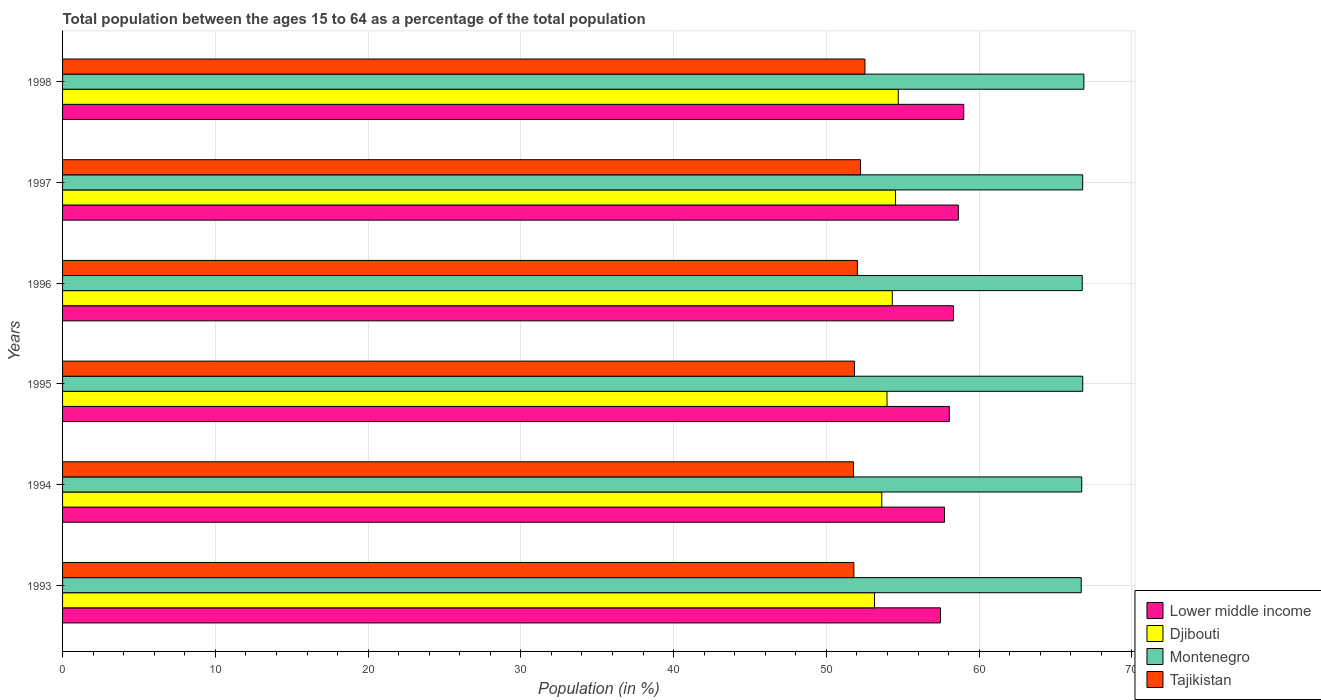How many different coloured bars are there?
Your response must be concise. 4. Are the number of bars per tick equal to the number of legend labels?
Provide a short and direct response. Yes. Are the number of bars on each tick of the Y-axis equal?
Your answer should be very brief. Yes. What is the label of the 5th group of bars from the top?
Give a very brief answer. 1994. What is the percentage of the population ages 15 to 64 in Djibouti in 1996?
Provide a short and direct response. 54.31. Across all years, what is the maximum percentage of the population ages 15 to 64 in Tajikistan?
Provide a succinct answer. 52.52. Across all years, what is the minimum percentage of the population ages 15 to 64 in Tajikistan?
Your answer should be compact. 51.77. What is the total percentage of the population ages 15 to 64 in Djibouti in the graph?
Your answer should be compact. 324.29. What is the difference between the percentage of the population ages 15 to 64 in Montenegro in 1993 and that in 1995?
Ensure brevity in your answer.  -0.1. What is the difference between the percentage of the population ages 15 to 64 in Tajikistan in 1993 and the percentage of the population ages 15 to 64 in Lower middle income in 1996?
Make the answer very short. -6.52. What is the average percentage of the population ages 15 to 64 in Montenegro per year?
Your answer should be compact. 66.76. In the year 1996, what is the difference between the percentage of the population ages 15 to 64 in Lower middle income and percentage of the population ages 15 to 64 in Djibouti?
Offer a terse response. 4. What is the ratio of the percentage of the population ages 15 to 64 in Lower middle income in 1995 to that in 1997?
Offer a very short reply. 0.99. What is the difference between the highest and the second highest percentage of the population ages 15 to 64 in Tajikistan?
Ensure brevity in your answer.  0.29. What is the difference between the highest and the lowest percentage of the population ages 15 to 64 in Tajikistan?
Offer a terse response. 0.75. What does the 4th bar from the top in 1994 represents?
Keep it short and to the point. Lower middle income. What does the 1st bar from the bottom in 1996 represents?
Give a very brief answer. Lower middle income. Are all the bars in the graph horizontal?
Ensure brevity in your answer.  Yes. How many years are there in the graph?
Offer a very short reply. 6. Are the values on the major ticks of X-axis written in scientific E-notation?
Offer a terse response. No. How many legend labels are there?
Make the answer very short. 4. What is the title of the graph?
Offer a terse response. Total population between the ages 15 to 64 as a percentage of the total population. Does "Benin" appear as one of the legend labels in the graph?
Give a very brief answer. No. What is the Population (in %) of Lower middle income in 1993?
Give a very brief answer. 57.47. What is the Population (in %) in Djibouti in 1993?
Your answer should be very brief. 53.15. What is the Population (in %) of Montenegro in 1993?
Ensure brevity in your answer.  66.68. What is the Population (in %) in Tajikistan in 1993?
Provide a succinct answer. 51.8. What is the Population (in %) in Lower middle income in 1994?
Provide a succinct answer. 57.73. What is the Population (in %) in Djibouti in 1994?
Make the answer very short. 53.62. What is the Population (in %) in Montenegro in 1994?
Ensure brevity in your answer.  66.71. What is the Population (in %) in Tajikistan in 1994?
Provide a short and direct response. 51.77. What is the Population (in %) in Lower middle income in 1995?
Your answer should be compact. 58.05. What is the Population (in %) of Djibouti in 1995?
Offer a very short reply. 53.97. What is the Population (in %) of Montenegro in 1995?
Provide a short and direct response. 66.78. What is the Population (in %) of Tajikistan in 1995?
Give a very brief answer. 51.84. What is the Population (in %) in Lower middle income in 1996?
Provide a succinct answer. 58.32. What is the Population (in %) of Djibouti in 1996?
Offer a terse response. 54.31. What is the Population (in %) of Montenegro in 1996?
Offer a terse response. 66.75. What is the Population (in %) in Tajikistan in 1996?
Make the answer very short. 52.03. What is the Population (in %) in Lower middle income in 1997?
Offer a terse response. 58.64. What is the Population (in %) in Djibouti in 1997?
Your answer should be very brief. 54.53. What is the Population (in %) of Montenegro in 1997?
Your answer should be very brief. 66.78. What is the Population (in %) in Tajikistan in 1997?
Keep it short and to the point. 52.24. What is the Population (in %) of Lower middle income in 1998?
Your answer should be compact. 58.99. What is the Population (in %) in Djibouti in 1998?
Ensure brevity in your answer.  54.71. What is the Population (in %) of Montenegro in 1998?
Provide a succinct answer. 66.85. What is the Population (in %) in Tajikistan in 1998?
Give a very brief answer. 52.52. Across all years, what is the maximum Population (in %) of Lower middle income?
Give a very brief answer. 58.99. Across all years, what is the maximum Population (in %) in Djibouti?
Your answer should be very brief. 54.71. Across all years, what is the maximum Population (in %) in Montenegro?
Make the answer very short. 66.85. Across all years, what is the maximum Population (in %) of Tajikistan?
Your answer should be very brief. 52.52. Across all years, what is the minimum Population (in %) in Lower middle income?
Your answer should be very brief. 57.47. Across all years, what is the minimum Population (in %) in Djibouti?
Your answer should be compact. 53.15. Across all years, what is the minimum Population (in %) in Montenegro?
Make the answer very short. 66.68. Across all years, what is the minimum Population (in %) in Tajikistan?
Provide a short and direct response. 51.77. What is the total Population (in %) of Lower middle income in the graph?
Make the answer very short. 349.19. What is the total Population (in %) of Djibouti in the graph?
Keep it short and to the point. 324.29. What is the total Population (in %) of Montenegro in the graph?
Offer a terse response. 400.55. What is the total Population (in %) of Tajikistan in the graph?
Your answer should be very brief. 312.19. What is the difference between the Population (in %) of Lower middle income in 1993 and that in 1994?
Make the answer very short. -0.27. What is the difference between the Population (in %) in Djibouti in 1993 and that in 1994?
Keep it short and to the point. -0.47. What is the difference between the Population (in %) in Montenegro in 1993 and that in 1994?
Your answer should be very brief. -0.03. What is the difference between the Population (in %) in Tajikistan in 1993 and that in 1994?
Ensure brevity in your answer.  0.02. What is the difference between the Population (in %) of Lower middle income in 1993 and that in 1995?
Provide a short and direct response. -0.58. What is the difference between the Population (in %) of Djibouti in 1993 and that in 1995?
Provide a succinct answer. -0.81. What is the difference between the Population (in %) of Montenegro in 1993 and that in 1995?
Keep it short and to the point. -0.1. What is the difference between the Population (in %) in Tajikistan in 1993 and that in 1995?
Your answer should be very brief. -0.04. What is the difference between the Population (in %) of Lower middle income in 1993 and that in 1996?
Your answer should be compact. -0.85. What is the difference between the Population (in %) in Djibouti in 1993 and that in 1996?
Keep it short and to the point. -1.16. What is the difference between the Population (in %) in Montenegro in 1993 and that in 1996?
Your answer should be compact. -0.07. What is the difference between the Population (in %) of Tajikistan in 1993 and that in 1996?
Offer a very short reply. -0.23. What is the difference between the Population (in %) of Lower middle income in 1993 and that in 1997?
Provide a succinct answer. -1.17. What is the difference between the Population (in %) in Djibouti in 1993 and that in 1997?
Offer a very short reply. -1.38. What is the difference between the Population (in %) of Montenegro in 1993 and that in 1997?
Provide a short and direct response. -0.1. What is the difference between the Population (in %) of Tajikistan in 1993 and that in 1997?
Your response must be concise. -0.44. What is the difference between the Population (in %) in Lower middle income in 1993 and that in 1998?
Offer a very short reply. -1.53. What is the difference between the Population (in %) of Djibouti in 1993 and that in 1998?
Offer a terse response. -1.55. What is the difference between the Population (in %) of Montenegro in 1993 and that in 1998?
Provide a short and direct response. -0.18. What is the difference between the Population (in %) in Tajikistan in 1993 and that in 1998?
Keep it short and to the point. -0.72. What is the difference between the Population (in %) of Lower middle income in 1994 and that in 1995?
Offer a terse response. -0.32. What is the difference between the Population (in %) in Djibouti in 1994 and that in 1995?
Ensure brevity in your answer.  -0.34. What is the difference between the Population (in %) of Montenegro in 1994 and that in 1995?
Provide a succinct answer. -0.07. What is the difference between the Population (in %) of Tajikistan in 1994 and that in 1995?
Give a very brief answer. -0.06. What is the difference between the Population (in %) of Lower middle income in 1994 and that in 1996?
Keep it short and to the point. -0.59. What is the difference between the Population (in %) of Djibouti in 1994 and that in 1996?
Make the answer very short. -0.69. What is the difference between the Population (in %) in Montenegro in 1994 and that in 1996?
Ensure brevity in your answer.  -0.03. What is the difference between the Population (in %) of Tajikistan in 1994 and that in 1996?
Your answer should be compact. -0.25. What is the difference between the Population (in %) in Lower middle income in 1994 and that in 1997?
Offer a terse response. -0.9. What is the difference between the Population (in %) of Djibouti in 1994 and that in 1997?
Offer a very short reply. -0.9. What is the difference between the Population (in %) in Montenegro in 1994 and that in 1997?
Your answer should be compact. -0.06. What is the difference between the Population (in %) of Tajikistan in 1994 and that in 1997?
Your response must be concise. -0.46. What is the difference between the Population (in %) of Lower middle income in 1994 and that in 1998?
Your answer should be compact. -1.26. What is the difference between the Population (in %) in Djibouti in 1994 and that in 1998?
Give a very brief answer. -1.08. What is the difference between the Population (in %) in Montenegro in 1994 and that in 1998?
Offer a very short reply. -0.14. What is the difference between the Population (in %) of Tajikistan in 1994 and that in 1998?
Offer a terse response. -0.75. What is the difference between the Population (in %) in Lower middle income in 1995 and that in 1996?
Provide a short and direct response. -0.27. What is the difference between the Population (in %) in Djibouti in 1995 and that in 1996?
Your answer should be very brief. -0.35. What is the difference between the Population (in %) of Montenegro in 1995 and that in 1996?
Offer a terse response. 0.03. What is the difference between the Population (in %) in Tajikistan in 1995 and that in 1996?
Offer a very short reply. -0.19. What is the difference between the Population (in %) in Lower middle income in 1995 and that in 1997?
Give a very brief answer. -0.59. What is the difference between the Population (in %) of Djibouti in 1995 and that in 1997?
Offer a terse response. -0.56. What is the difference between the Population (in %) in Montenegro in 1995 and that in 1997?
Your answer should be compact. 0. What is the difference between the Population (in %) in Tajikistan in 1995 and that in 1997?
Provide a succinct answer. -0.4. What is the difference between the Population (in %) of Lower middle income in 1995 and that in 1998?
Offer a very short reply. -0.94. What is the difference between the Population (in %) of Djibouti in 1995 and that in 1998?
Offer a very short reply. -0.74. What is the difference between the Population (in %) of Montenegro in 1995 and that in 1998?
Your answer should be compact. -0.08. What is the difference between the Population (in %) of Tajikistan in 1995 and that in 1998?
Provide a succinct answer. -0.69. What is the difference between the Population (in %) of Lower middle income in 1996 and that in 1997?
Offer a very short reply. -0.32. What is the difference between the Population (in %) in Djibouti in 1996 and that in 1997?
Keep it short and to the point. -0.21. What is the difference between the Population (in %) of Montenegro in 1996 and that in 1997?
Provide a short and direct response. -0.03. What is the difference between the Population (in %) in Tajikistan in 1996 and that in 1997?
Your answer should be very brief. -0.21. What is the difference between the Population (in %) in Lower middle income in 1996 and that in 1998?
Provide a short and direct response. -0.67. What is the difference between the Population (in %) of Djibouti in 1996 and that in 1998?
Provide a succinct answer. -0.39. What is the difference between the Population (in %) in Montenegro in 1996 and that in 1998?
Offer a terse response. -0.11. What is the difference between the Population (in %) of Tajikistan in 1996 and that in 1998?
Provide a succinct answer. -0.5. What is the difference between the Population (in %) of Lower middle income in 1997 and that in 1998?
Provide a succinct answer. -0.36. What is the difference between the Population (in %) of Djibouti in 1997 and that in 1998?
Your answer should be very brief. -0.18. What is the difference between the Population (in %) of Montenegro in 1997 and that in 1998?
Keep it short and to the point. -0.08. What is the difference between the Population (in %) in Tajikistan in 1997 and that in 1998?
Ensure brevity in your answer.  -0.29. What is the difference between the Population (in %) in Lower middle income in 1993 and the Population (in %) in Djibouti in 1994?
Provide a succinct answer. 3.84. What is the difference between the Population (in %) of Lower middle income in 1993 and the Population (in %) of Montenegro in 1994?
Your answer should be compact. -9.25. What is the difference between the Population (in %) of Lower middle income in 1993 and the Population (in %) of Tajikistan in 1994?
Give a very brief answer. 5.69. What is the difference between the Population (in %) in Djibouti in 1993 and the Population (in %) in Montenegro in 1994?
Give a very brief answer. -13.56. What is the difference between the Population (in %) in Djibouti in 1993 and the Population (in %) in Tajikistan in 1994?
Your response must be concise. 1.38. What is the difference between the Population (in %) in Montenegro in 1993 and the Population (in %) in Tajikistan in 1994?
Provide a short and direct response. 14.91. What is the difference between the Population (in %) in Lower middle income in 1993 and the Population (in %) in Djibouti in 1995?
Give a very brief answer. 3.5. What is the difference between the Population (in %) in Lower middle income in 1993 and the Population (in %) in Montenegro in 1995?
Your response must be concise. -9.31. What is the difference between the Population (in %) of Lower middle income in 1993 and the Population (in %) of Tajikistan in 1995?
Provide a short and direct response. 5.63. What is the difference between the Population (in %) in Djibouti in 1993 and the Population (in %) in Montenegro in 1995?
Your answer should be compact. -13.63. What is the difference between the Population (in %) of Djibouti in 1993 and the Population (in %) of Tajikistan in 1995?
Your answer should be compact. 1.32. What is the difference between the Population (in %) of Montenegro in 1993 and the Population (in %) of Tajikistan in 1995?
Your answer should be compact. 14.84. What is the difference between the Population (in %) in Lower middle income in 1993 and the Population (in %) in Djibouti in 1996?
Your response must be concise. 3.15. What is the difference between the Population (in %) of Lower middle income in 1993 and the Population (in %) of Montenegro in 1996?
Provide a short and direct response. -9.28. What is the difference between the Population (in %) in Lower middle income in 1993 and the Population (in %) in Tajikistan in 1996?
Your answer should be very brief. 5.44. What is the difference between the Population (in %) in Djibouti in 1993 and the Population (in %) in Montenegro in 1996?
Provide a short and direct response. -13.59. What is the difference between the Population (in %) in Djibouti in 1993 and the Population (in %) in Tajikistan in 1996?
Your response must be concise. 1.13. What is the difference between the Population (in %) of Montenegro in 1993 and the Population (in %) of Tajikistan in 1996?
Give a very brief answer. 14.65. What is the difference between the Population (in %) of Lower middle income in 1993 and the Population (in %) of Djibouti in 1997?
Provide a short and direct response. 2.94. What is the difference between the Population (in %) in Lower middle income in 1993 and the Population (in %) in Montenegro in 1997?
Your answer should be compact. -9.31. What is the difference between the Population (in %) of Lower middle income in 1993 and the Population (in %) of Tajikistan in 1997?
Provide a short and direct response. 5.23. What is the difference between the Population (in %) of Djibouti in 1993 and the Population (in %) of Montenegro in 1997?
Provide a short and direct response. -13.62. What is the difference between the Population (in %) in Djibouti in 1993 and the Population (in %) in Tajikistan in 1997?
Give a very brief answer. 0.92. What is the difference between the Population (in %) in Montenegro in 1993 and the Population (in %) in Tajikistan in 1997?
Ensure brevity in your answer.  14.44. What is the difference between the Population (in %) of Lower middle income in 1993 and the Population (in %) of Djibouti in 1998?
Make the answer very short. 2.76. What is the difference between the Population (in %) in Lower middle income in 1993 and the Population (in %) in Montenegro in 1998?
Offer a terse response. -9.39. What is the difference between the Population (in %) in Lower middle income in 1993 and the Population (in %) in Tajikistan in 1998?
Make the answer very short. 4.94. What is the difference between the Population (in %) in Djibouti in 1993 and the Population (in %) in Montenegro in 1998?
Your answer should be very brief. -13.7. What is the difference between the Population (in %) in Djibouti in 1993 and the Population (in %) in Tajikistan in 1998?
Keep it short and to the point. 0.63. What is the difference between the Population (in %) in Montenegro in 1993 and the Population (in %) in Tajikistan in 1998?
Offer a very short reply. 14.16. What is the difference between the Population (in %) in Lower middle income in 1994 and the Population (in %) in Djibouti in 1995?
Offer a terse response. 3.77. What is the difference between the Population (in %) in Lower middle income in 1994 and the Population (in %) in Montenegro in 1995?
Your answer should be very brief. -9.05. What is the difference between the Population (in %) of Lower middle income in 1994 and the Population (in %) of Tajikistan in 1995?
Keep it short and to the point. 5.9. What is the difference between the Population (in %) in Djibouti in 1994 and the Population (in %) in Montenegro in 1995?
Keep it short and to the point. -13.16. What is the difference between the Population (in %) in Djibouti in 1994 and the Population (in %) in Tajikistan in 1995?
Your answer should be compact. 1.79. What is the difference between the Population (in %) of Montenegro in 1994 and the Population (in %) of Tajikistan in 1995?
Give a very brief answer. 14.88. What is the difference between the Population (in %) of Lower middle income in 1994 and the Population (in %) of Djibouti in 1996?
Provide a succinct answer. 3.42. What is the difference between the Population (in %) of Lower middle income in 1994 and the Population (in %) of Montenegro in 1996?
Your response must be concise. -9.01. What is the difference between the Population (in %) of Lower middle income in 1994 and the Population (in %) of Tajikistan in 1996?
Keep it short and to the point. 5.71. What is the difference between the Population (in %) of Djibouti in 1994 and the Population (in %) of Montenegro in 1996?
Provide a succinct answer. -13.12. What is the difference between the Population (in %) of Djibouti in 1994 and the Population (in %) of Tajikistan in 1996?
Ensure brevity in your answer.  1.6. What is the difference between the Population (in %) of Montenegro in 1994 and the Population (in %) of Tajikistan in 1996?
Provide a short and direct response. 14.69. What is the difference between the Population (in %) in Lower middle income in 1994 and the Population (in %) in Djibouti in 1997?
Give a very brief answer. 3.2. What is the difference between the Population (in %) of Lower middle income in 1994 and the Population (in %) of Montenegro in 1997?
Your answer should be compact. -9.04. What is the difference between the Population (in %) in Lower middle income in 1994 and the Population (in %) in Tajikistan in 1997?
Ensure brevity in your answer.  5.5. What is the difference between the Population (in %) in Djibouti in 1994 and the Population (in %) in Montenegro in 1997?
Your answer should be very brief. -13.15. What is the difference between the Population (in %) of Djibouti in 1994 and the Population (in %) of Tajikistan in 1997?
Give a very brief answer. 1.39. What is the difference between the Population (in %) in Montenegro in 1994 and the Population (in %) in Tajikistan in 1997?
Give a very brief answer. 14.48. What is the difference between the Population (in %) of Lower middle income in 1994 and the Population (in %) of Djibouti in 1998?
Your response must be concise. 3.03. What is the difference between the Population (in %) in Lower middle income in 1994 and the Population (in %) in Montenegro in 1998?
Your response must be concise. -9.12. What is the difference between the Population (in %) in Lower middle income in 1994 and the Population (in %) in Tajikistan in 1998?
Your answer should be very brief. 5.21. What is the difference between the Population (in %) in Djibouti in 1994 and the Population (in %) in Montenegro in 1998?
Give a very brief answer. -13.23. What is the difference between the Population (in %) in Djibouti in 1994 and the Population (in %) in Tajikistan in 1998?
Make the answer very short. 1.1. What is the difference between the Population (in %) in Montenegro in 1994 and the Population (in %) in Tajikistan in 1998?
Offer a very short reply. 14.19. What is the difference between the Population (in %) of Lower middle income in 1995 and the Population (in %) of Djibouti in 1996?
Give a very brief answer. 3.73. What is the difference between the Population (in %) in Lower middle income in 1995 and the Population (in %) in Montenegro in 1996?
Your response must be concise. -8.7. What is the difference between the Population (in %) in Lower middle income in 1995 and the Population (in %) in Tajikistan in 1996?
Your answer should be very brief. 6.02. What is the difference between the Population (in %) of Djibouti in 1995 and the Population (in %) of Montenegro in 1996?
Provide a succinct answer. -12.78. What is the difference between the Population (in %) in Djibouti in 1995 and the Population (in %) in Tajikistan in 1996?
Provide a short and direct response. 1.94. What is the difference between the Population (in %) in Montenegro in 1995 and the Population (in %) in Tajikistan in 1996?
Offer a very short reply. 14.75. What is the difference between the Population (in %) of Lower middle income in 1995 and the Population (in %) of Djibouti in 1997?
Provide a succinct answer. 3.52. What is the difference between the Population (in %) of Lower middle income in 1995 and the Population (in %) of Montenegro in 1997?
Your response must be concise. -8.73. What is the difference between the Population (in %) of Lower middle income in 1995 and the Population (in %) of Tajikistan in 1997?
Offer a very short reply. 5.81. What is the difference between the Population (in %) of Djibouti in 1995 and the Population (in %) of Montenegro in 1997?
Give a very brief answer. -12.81. What is the difference between the Population (in %) of Djibouti in 1995 and the Population (in %) of Tajikistan in 1997?
Ensure brevity in your answer.  1.73. What is the difference between the Population (in %) of Montenegro in 1995 and the Population (in %) of Tajikistan in 1997?
Your answer should be compact. 14.54. What is the difference between the Population (in %) of Lower middle income in 1995 and the Population (in %) of Djibouti in 1998?
Your answer should be compact. 3.34. What is the difference between the Population (in %) of Lower middle income in 1995 and the Population (in %) of Montenegro in 1998?
Give a very brief answer. -8.81. What is the difference between the Population (in %) of Lower middle income in 1995 and the Population (in %) of Tajikistan in 1998?
Keep it short and to the point. 5.52. What is the difference between the Population (in %) in Djibouti in 1995 and the Population (in %) in Montenegro in 1998?
Make the answer very short. -12.89. What is the difference between the Population (in %) of Djibouti in 1995 and the Population (in %) of Tajikistan in 1998?
Provide a succinct answer. 1.44. What is the difference between the Population (in %) in Montenegro in 1995 and the Population (in %) in Tajikistan in 1998?
Ensure brevity in your answer.  14.26. What is the difference between the Population (in %) in Lower middle income in 1996 and the Population (in %) in Djibouti in 1997?
Your answer should be very brief. 3.79. What is the difference between the Population (in %) in Lower middle income in 1996 and the Population (in %) in Montenegro in 1997?
Offer a very short reply. -8.46. What is the difference between the Population (in %) in Lower middle income in 1996 and the Population (in %) in Tajikistan in 1997?
Ensure brevity in your answer.  6.08. What is the difference between the Population (in %) in Djibouti in 1996 and the Population (in %) in Montenegro in 1997?
Your answer should be very brief. -12.46. What is the difference between the Population (in %) in Djibouti in 1996 and the Population (in %) in Tajikistan in 1997?
Your response must be concise. 2.08. What is the difference between the Population (in %) of Montenegro in 1996 and the Population (in %) of Tajikistan in 1997?
Your answer should be compact. 14.51. What is the difference between the Population (in %) in Lower middle income in 1996 and the Population (in %) in Djibouti in 1998?
Ensure brevity in your answer.  3.61. What is the difference between the Population (in %) in Lower middle income in 1996 and the Population (in %) in Montenegro in 1998?
Provide a short and direct response. -8.54. What is the difference between the Population (in %) in Lower middle income in 1996 and the Population (in %) in Tajikistan in 1998?
Your answer should be compact. 5.8. What is the difference between the Population (in %) of Djibouti in 1996 and the Population (in %) of Montenegro in 1998?
Ensure brevity in your answer.  -12.54. What is the difference between the Population (in %) in Djibouti in 1996 and the Population (in %) in Tajikistan in 1998?
Provide a succinct answer. 1.79. What is the difference between the Population (in %) of Montenegro in 1996 and the Population (in %) of Tajikistan in 1998?
Ensure brevity in your answer.  14.22. What is the difference between the Population (in %) in Lower middle income in 1997 and the Population (in %) in Djibouti in 1998?
Make the answer very short. 3.93. What is the difference between the Population (in %) in Lower middle income in 1997 and the Population (in %) in Montenegro in 1998?
Offer a terse response. -8.22. What is the difference between the Population (in %) in Lower middle income in 1997 and the Population (in %) in Tajikistan in 1998?
Ensure brevity in your answer.  6.11. What is the difference between the Population (in %) of Djibouti in 1997 and the Population (in %) of Montenegro in 1998?
Offer a very short reply. -12.33. What is the difference between the Population (in %) in Djibouti in 1997 and the Population (in %) in Tajikistan in 1998?
Your answer should be compact. 2. What is the difference between the Population (in %) of Montenegro in 1997 and the Population (in %) of Tajikistan in 1998?
Provide a short and direct response. 14.25. What is the average Population (in %) of Lower middle income per year?
Your answer should be compact. 58.2. What is the average Population (in %) of Djibouti per year?
Provide a short and direct response. 54.05. What is the average Population (in %) of Montenegro per year?
Your response must be concise. 66.76. What is the average Population (in %) of Tajikistan per year?
Keep it short and to the point. 52.03. In the year 1993, what is the difference between the Population (in %) in Lower middle income and Population (in %) in Djibouti?
Offer a terse response. 4.31. In the year 1993, what is the difference between the Population (in %) of Lower middle income and Population (in %) of Montenegro?
Offer a terse response. -9.21. In the year 1993, what is the difference between the Population (in %) of Lower middle income and Population (in %) of Tajikistan?
Give a very brief answer. 5.67. In the year 1993, what is the difference between the Population (in %) in Djibouti and Population (in %) in Montenegro?
Make the answer very short. -13.53. In the year 1993, what is the difference between the Population (in %) in Djibouti and Population (in %) in Tajikistan?
Make the answer very short. 1.35. In the year 1993, what is the difference between the Population (in %) in Montenegro and Population (in %) in Tajikistan?
Offer a very short reply. 14.88. In the year 1994, what is the difference between the Population (in %) in Lower middle income and Population (in %) in Djibouti?
Keep it short and to the point. 4.11. In the year 1994, what is the difference between the Population (in %) in Lower middle income and Population (in %) in Montenegro?
Give a very brief answer. -8.98. In the year 1994, what is the difference between the Population (in %) in Lower middle income and Population (in %) in Tajikistan?
Provide a short and direct response. 5.96. In the year 1994, what is the difference between the Population (in %) of Djibouti and Population (in %) of Montenegro?
Your response must be concise. -13.09. In the year 1994, what is the difference between the Population (in %) of Djibouti and Population (in %) of Tajikistan?
Offer a terse response. 1.85. In the year 1994, what is the difference between the Population (in %) in Montenegro and Population (in %) in Tajikistan?
Your answer should be very brief. 14.94. In the year 1995, what is the difference between the Population (in %) in Lower middle income and Population (in %) in Djibouti?
Ensure brevity in your answer.  4.08. In the year 1995, what is the difference between the Population (in %) of Lower middle income and Population (in %) of Montenegro?
Ensure brevity in your answer.  -8.73. In the year 1995, what is the difference between the Population (in %) in Lower middle income and Population (in %) in Tajikistan?
Your answer should be compact. 6.21. In the year 1995, what is the difference between the Population (in %) of Djibouti and Population (in %) of Montenegro?
Keep it short and to the point. -12.81. In the year 1995, what is the difference between the Population (in %) of Djibouti and Population (in %) of Tajikistan?
Provide a succinct answer. 2.13. In the year 1995, what is the difference between the Population (in %) in Montenegro and Population (in %) in Tajikistan?
Offer a very short reply. 14.94. In the year 1996, what is the difference between the Population (in %) in Lower middle income and Population (in %) in Djibouti?
Make the answer very short. 4. In the year 1996, what is the difference between the Population (in %) of Lower middle income and Population (in %) of Montenegro?
Your answer should be very brief. -8.43. In the year 1996, what is the difference between the Population (in %) in Lower middle income and Population (in %) in Tajikistan?
Ensure brevity in your answer.  6.29. In the year 1996, what is the difference between the Population (in %) in Djibouti and Population (in %) in Montenegro?
Your answer should be very brief. -12.43. In the year 1996, what is the difference between the Population (in %) in Djibouti and Population (in %) in Tajikistan?
Your answer should be very brief. 2.29. In the year 1996, what is the difference between the Population (in %) of Montenegro and Population (in %) of Tajikistan?
Give a very brief answer. 14.72. In the year 1997, what is the difference between the Population (in %) of Lower middle income and Population (in %) of Djibouti?
Keep it short and to the point. 4.11. In the year 1997, what is the difference between the Population (in %) of Lower middle income and Population (in %) of Montenegro?
Make the answer very short. -8.14. In the year 1997, what is the difference between the Population (in %) of Lower middle income and Population (in %) of Tajikistan?
Offer a terse response. 6.4. In the year 1997, what is the difference between the Population (in %) of Djibouti and Population (in %) of Montenegro?
Your answer should be compact. -12.25. In the year 1997, what is the difference between the Population (in %) of Djibouti and Population (in %) of Tajikistan?
Keep it short and to the point. 2.29. In the year 1997, what is the difference between the Population (in %) of Montenegro and Population (in %) of Tajikistan?
Keep it short and to the point. 14.54. In the year 1998, what is the difference between the Population (in %) of Lower middle income and Population (in %) of Djibouti?
Ensure brevity in your answer.  4.29. In the year 1998, what is the difference between the Population (in %) of Lower middle income and Population (in %) of Montenegro?
Ensure brevity in your answer.  -7.86. In the year 1998, what is the difference between the Population (in %) of Lower middle income and Population (in %) of Tajikistan?
Make the answer very short. 6.47. In the year 1998, what is the difference between the Population (in %) of Djibouti and Population (in %) of Montenegro?
Ensure brevity in your answer.  -12.15. In the year 1998, what is the difference between the Population (in %) of Djibouti and Population (in %) of Tajikistan?
Offer a very short reply. 2.18. In the year 1998, what is the difference between the Population (in %) in Montenegro and Population (in %) in Tajikistan?
Provide a short and direct response. 14.33. What is the ratio of the Population (in %) in Lower middle income in 1993 to that in 1994?
Offer a very short reply. 1. What is the ratio of the Population (in %) in Djibouti in 1993 to that in 1994?
Your answer should be compact. 0.99. What is the ratio of the Population (in %) in Tajikistan in 1993 to that in 1994?
Make the answer very short. 1. What is the ratio of the Population (in %) in Djibouti in 1993 to that in 1995?
Make the answer very short. 0.98. What is the ratio of the Population (in %) in Lower middle income in 1993 to that in 1996?
Give a very brief answer. 0.99. What is the ratio of the Population (in %) in Djibouti in 1993 to that in 1996?
Give a very brief answer. 0.98. What is the ratio of the Population (in %) in Tajikistan in 1993 to that in 1996?
Your answer should be compact. 1. What is the ratio of the Population (in %) of Djibouti in 1993 to that in 1997?
Offer a very short reply. 0.97. What is the ratio of the Population (in %) of Tajikistan in 1993 to that in 1997?
Provide a succinct answer. 0.99. What is the ratio of the Population (in %) in Lower middle income in 1993 to that in 1998?
Offer a very short reply. 0.97. What is the ratio of the Population (in %) of Djibouti in 1993 to that in 1998?
Offer a terse response. 0.97. What is the ratio of the Population (in %) in Montenegro in 1993 to that in 1998?
Your answer should be very brief. 1. What is the ratio of the Population (in %) of Tajikistan in 1993 to that in 1998?
Keep it short and to the point. 0.99. What is the ratio of the Population (in %) in Lower middle income in 1994 to that in 1995?
Give a very brief answer. 0.99. What is the ratio of the Population (in %) of Montenegro in 1994 to that in 1995?
Your response must be concise. 1. What is the ratio of the Population (in %) of Tajikistan in 1994 to that in 1995?
Your response must be concise. 1. What is the ratio of the Population (in %) of Djibouti in 1994 to that in 1996?
Offer a terse response. 0.99. What is the ratio of the Population (in %) of Tajikistan in 1994 to that in 1996?
Give a very brief answer. 1. What is the ratio of the Population (in %) of Lower middle income in 1994 to that in 1997?
Make the answer very short. 0.98. What is the ratio of the Population (in %) in Djibouti in 1994 to that in 1997?
Offer a terse response. 0.98. What is the ratio of the Population (in %) in Tajikistan in 1994 to that in 1997?
Provide a succinct answer. 0.99. What is the ratio of the Population (in %) of Lower middle income in 1994 to that in 1998?
Ensure brevity in your answer.  0.98. What is the ratio of the Population (in %) in Djibouti in 1994 to that in 1998?
Provide a succinct answer. 0.98. What is the ratio of the Population (in %) in Montenegro in 1994 to that in 1998?
Your answer should be compact. 1. What is the ratio of the Population (in %) in Tajikistan in 1994 to that in 1998?
Make the answer very short. 0.99. What is the ratio of the Population (in %) in Lower middle income in 1995 to that in 1996?
Make the answer very short. 1. What is the ratio of the Population (in %) of Djibouti in 1995 to that in 1996?
Your answer should be compact. 0.99. What is the ratio of the Population (in %) in Montenegro in 1995 to that in 1996?
Provide a short and direct response. 1. What is the ratio of the Population (in %) of Tajikistan in 1995 to that in 1996?
Your answer should be very brief. 1. What is the ratio of the Population (in %) in Lower middle income in 1995 to that in 1997?
Your response must be concise. 0.99. What is the ratio of the Population (in %) of Montenegro in 1995 to that in 1997?
Your answer should be compact. 1. What is the ratio of the Population (in %) of Djibouti in 1995 to that in 1998?
Keep it short and to the point. 0.99. What is the ratio of the Population (in %) in Montenegro in 1995 to that in 1998?
Make the answer very short. 1. What is the ratio of the Population (in %) in Tajikistan in 1995 to that in 1998?
Give a very brief answer. 0.99. What is the ratio of the Population (in %) in Djibouti in 1996 to that in 1997?
Your answer should be very brief. 1. What is the ratio of the Population (in %) of Tajikistan in 1996 to that in 1997?
Keep it short and to the point. 1. What is the ratio of the Population (in %) in Tajikistan in 1996 to that in 1998?
Make the answer very short. 0.99. What is the ratio of the Population (in %) of Lower middle income in 1997 to that in 1998?
Offer a terse response. 0.99. What is the ratio of the Population (in %) of Djibouti in 1997 to that in 1998?
Give a very brief answer. 1. What is the difference between the highest and the second highest Population (in %) of Lower middle income?
Provide a short and direct response. 0.36. What is the difference between the highest and the second highest Population (in %) of Djibouti?
Your answer should be very brief. 0.18. What is the difference between the highest and the second highest Population (in %) of Montenegro?
Your answer should be very brief. 0.08. What is the difference between the highest and the second highest Population (in %) of Tajikistan?
Your response must be concise. 0.29. What is the difference between the highest and the lowest Population (in %) of Lower middle income?
Provide a succinct answer. 1.53. What is the difference between the highest and the lowest Population (in %) in Djibouti?
Provide a succinct answer. 1.55. What is the difference between the highest and the lowest Population (in %) in Montenegro?
Make the answer very short. 0.18. What is the difference between the highest and the lowest Population (in %) of Tajikistan?
Make the answer very short. 0.75. 